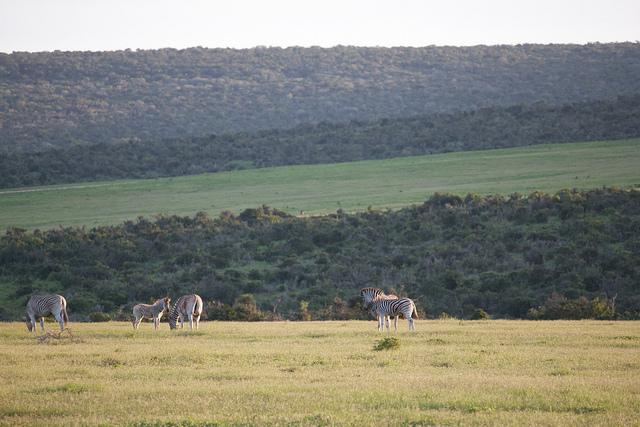What are the zebras looking at on the grass?

Choices:
A) strangers
B) food
C) mountains
D) friends food 